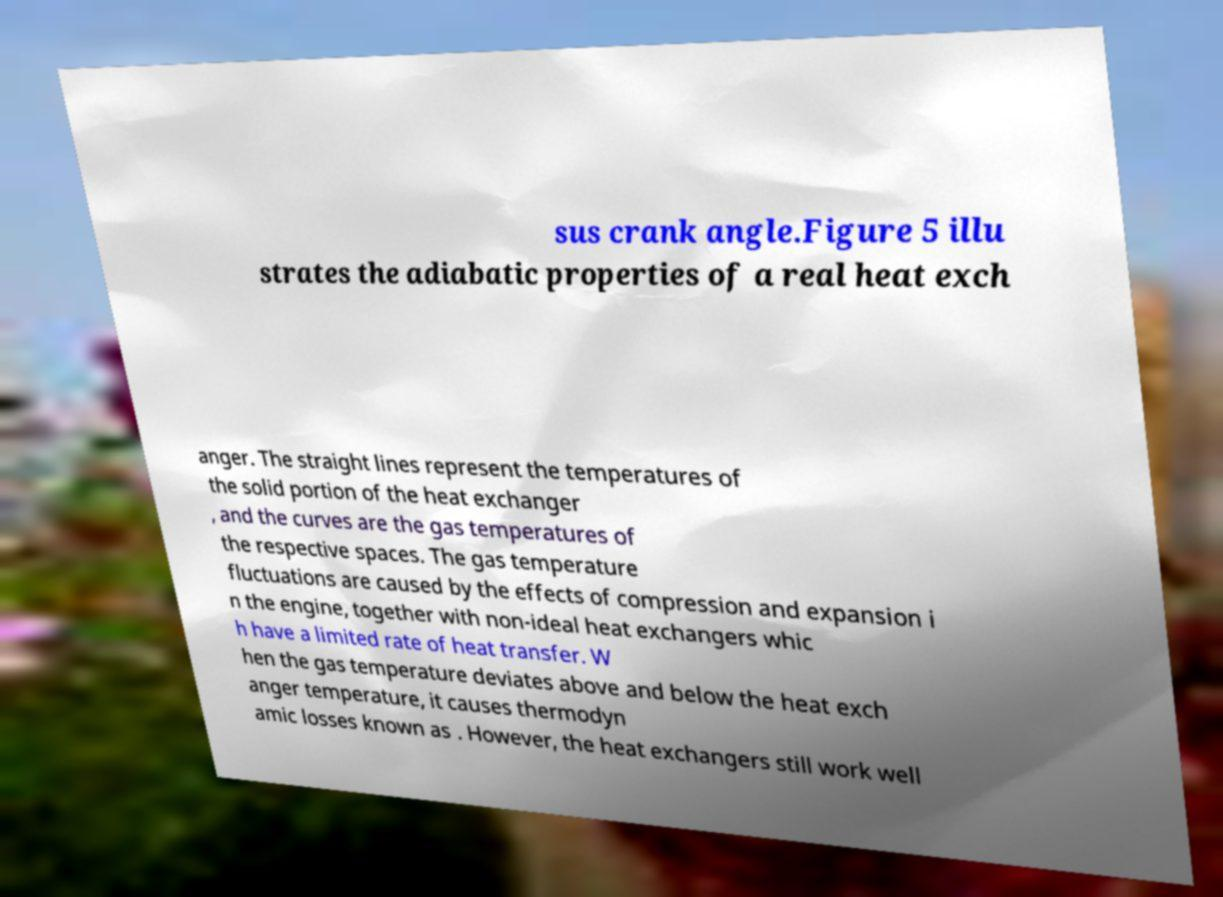For documentation purposes, I need the text within this image transcribed. Could you provide that? sus crank angle.Figure 5 illu strates the adiabatic properties of a real heat exch anger. The straight lines represent the temperatures of the solid portion of the heat exchanger , and the curves are the gas temperatures of the respective spaces. The gas temperature fluctuations are caused by the effects of compression and expansion i n the engine, together with non-ideal heat exchangers whic h have a limited rate of heat transfer. W hen the gas temperature deviates above and below the heat exch anger temperature, it causes thermodyn amic losses known as . However, the heat exchangers still work well 